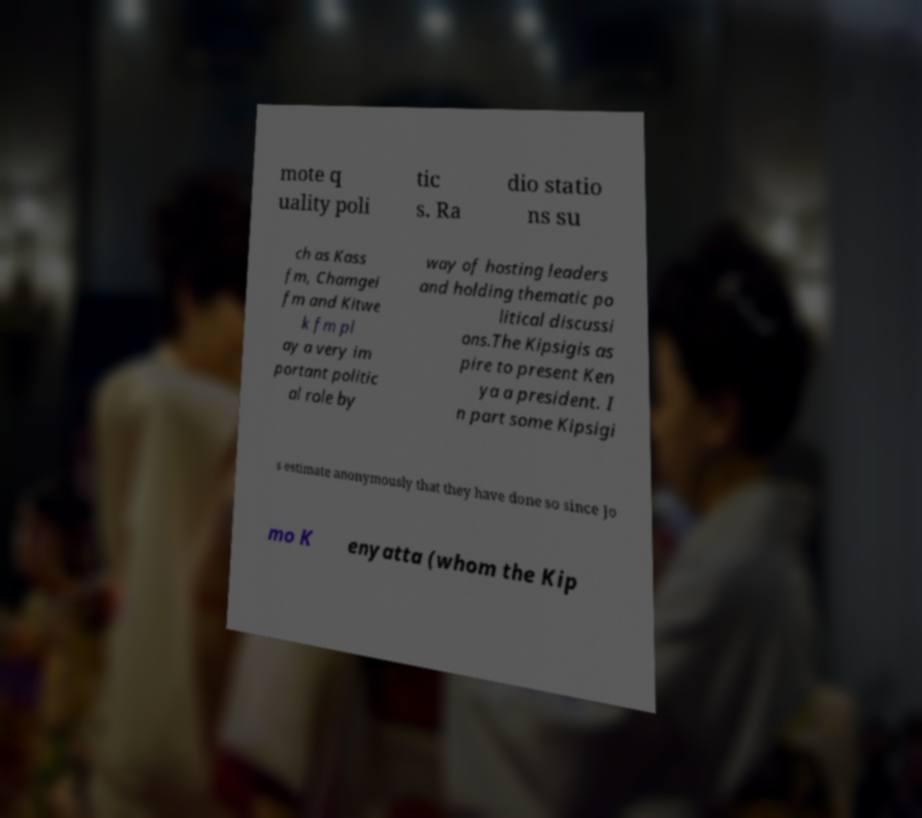Could you extract and type out the text from this image? mote q uality poli tic s. Ra dio statio ns su ch as Kass fm, Chamgei fm and Kitwe k fm pl ay a very im portant politic al role by way of hosting leaders and holding thematic po litical discussi ons.The Kipsigis as pire to present Ken ya a president. I n part some Kipsigi s estimate anonymously that they have done so since Jo mo K enyatta (whom the Kip 